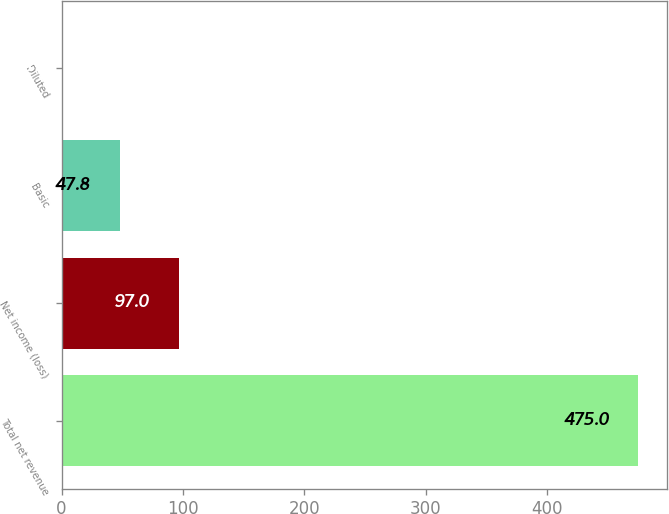<chart> <loc_0><loc_0><loc_500><loc_500><bar_chart><fcel>Total net revenue<fcel>Net income (loss)<fcel>Basic<fcel>Diluted<nl><fcel>475<fcel>97<fcel>47.8<fcel>0.33<nl></chart> 